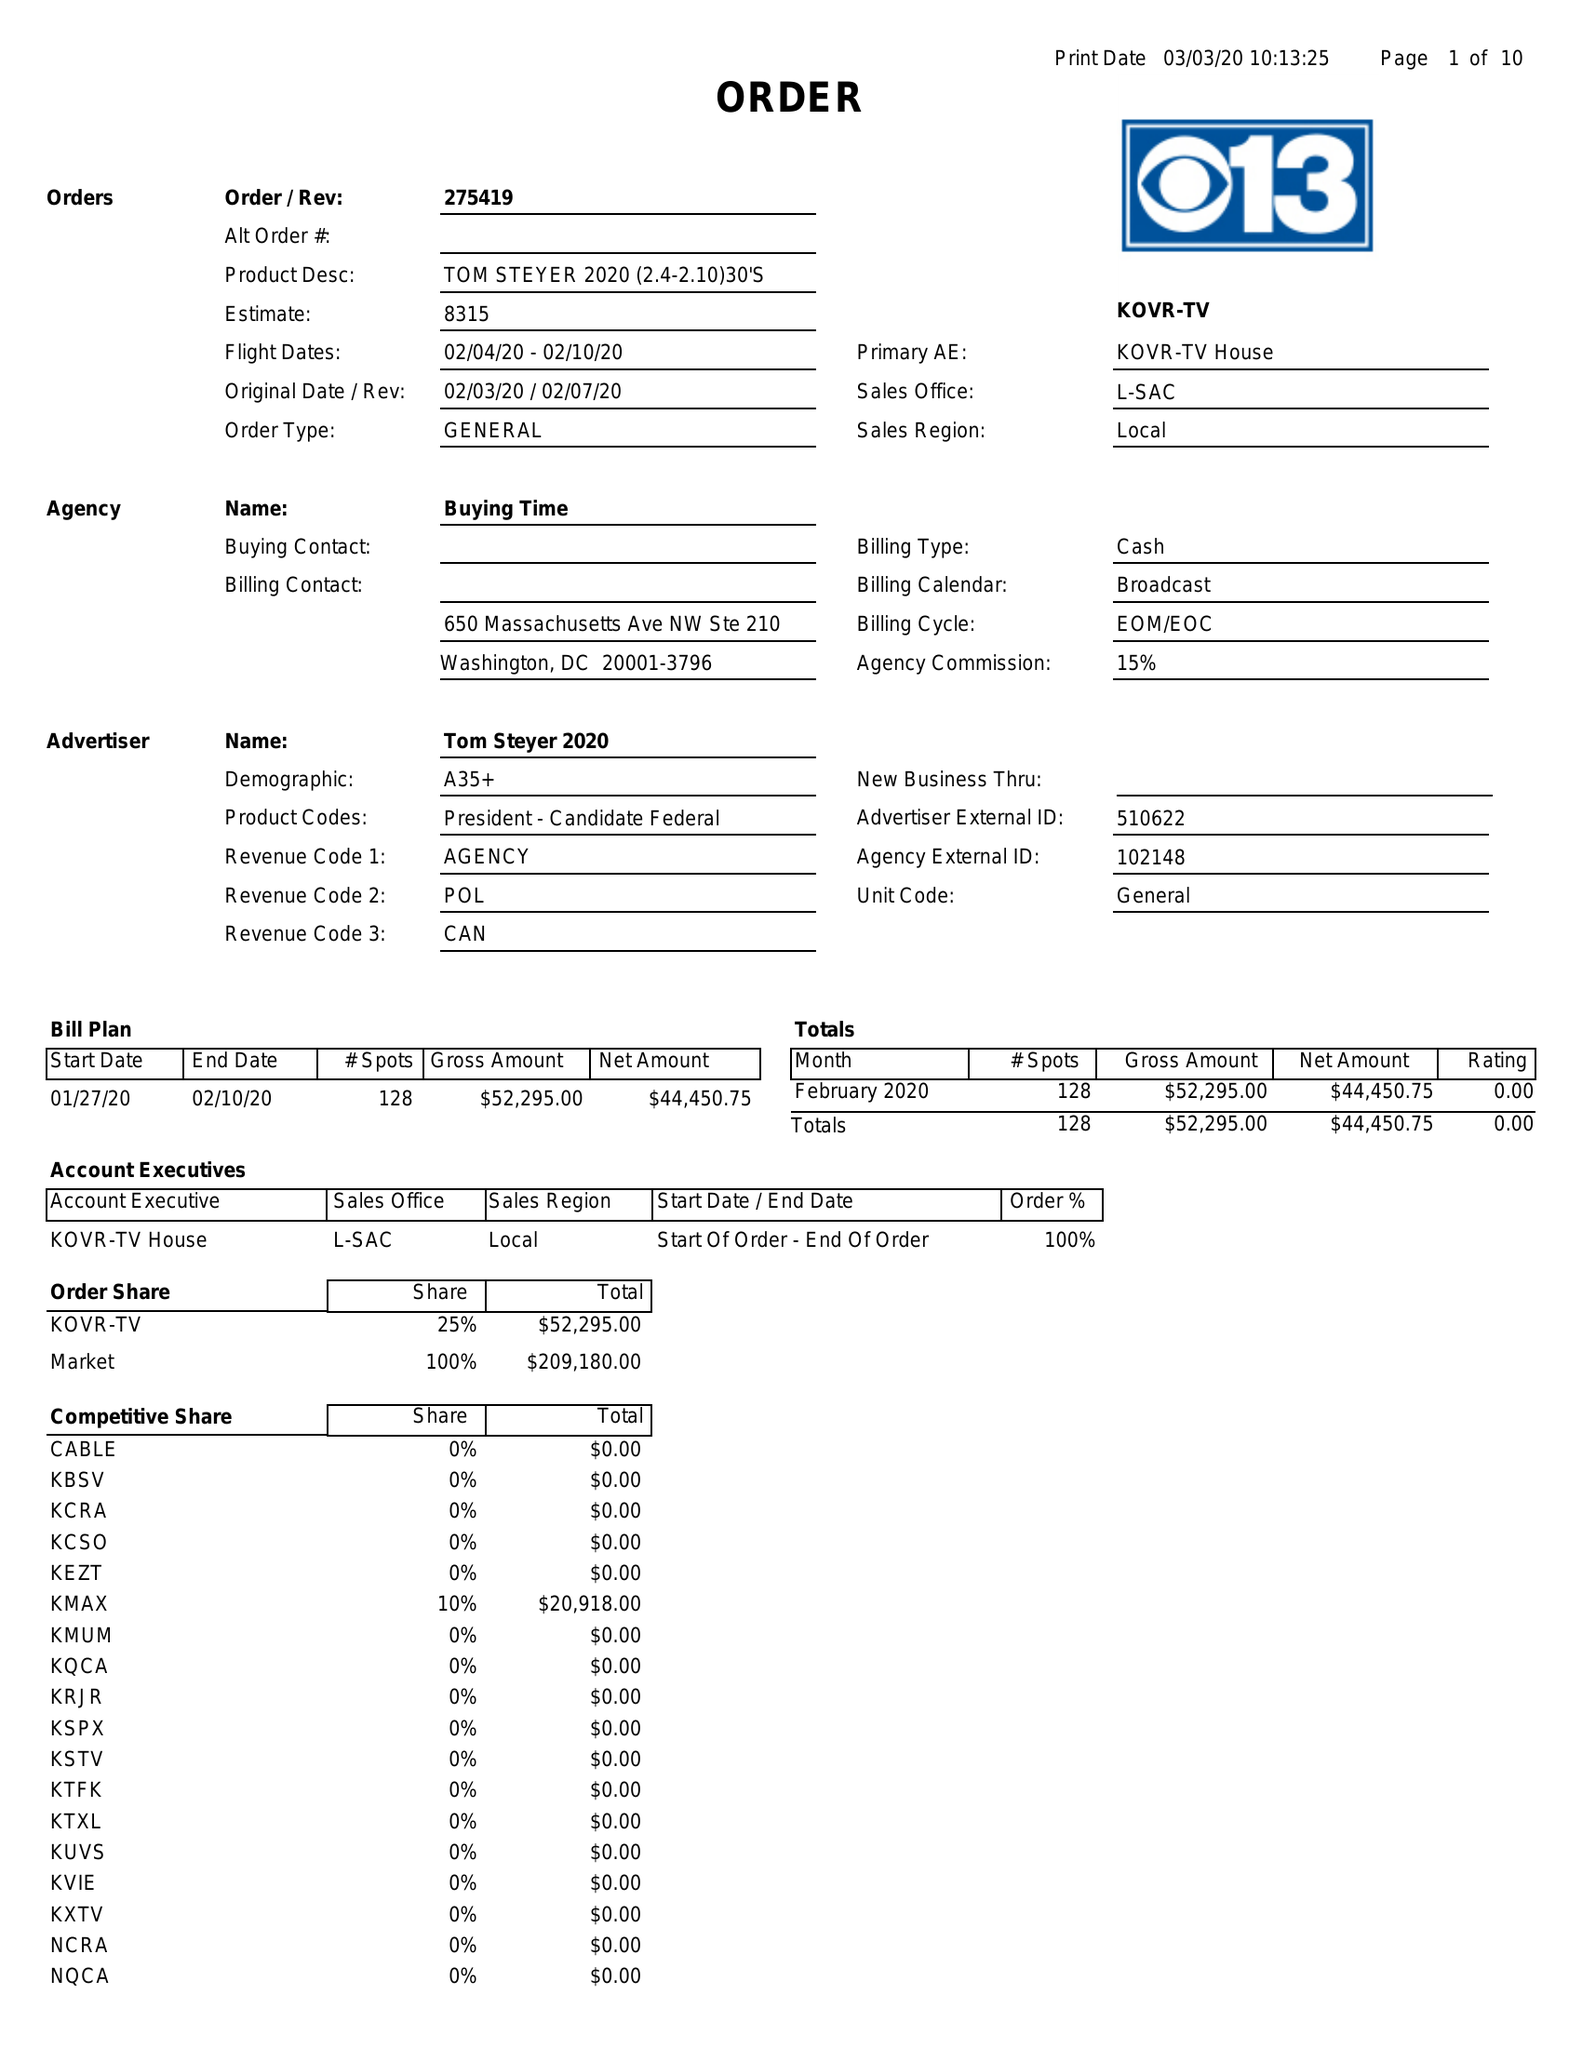What is the value for the gross_amount?
Answer the question using a single word or phrase. 52295.00 